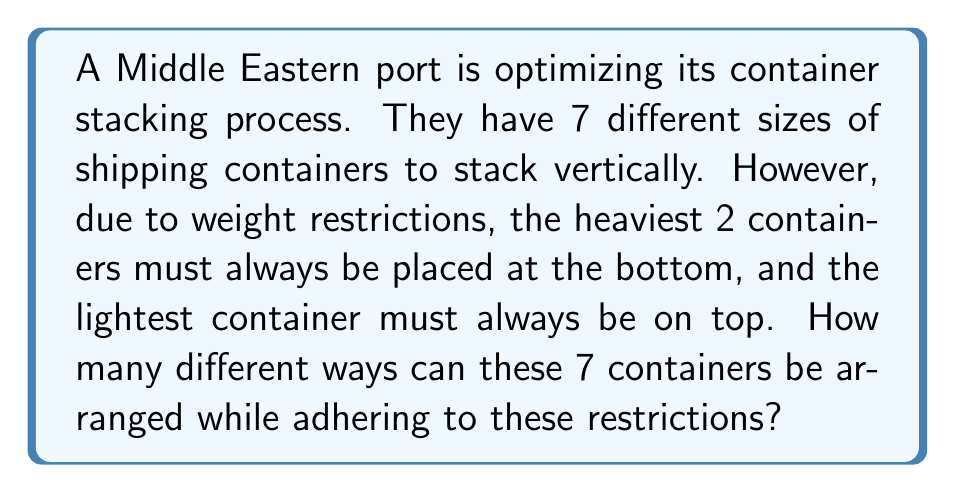Give your solution to this math problem. Let's approach this step-by-step:

1) First, we need to recognize that this is a permutation problem with restrictions.

2) We have 7 containers in total, but their positions are partially fixed:
   - The heaviest 2 containers must be at the bottom (in either order)
   - The lightest container must be on top
   - The remaining 4 containers can be arranged freely in the middle

3) Let's break down the problem:
   a) For the bottom 2 positions, we have 2! = 2 ways to arrange the heaviest containers
   b) The top position is fixed with the lightest container
   c) The middle 4 positions can be arranged in 4! ways

4) According to the multiplication principle, we multiply these together:

   $$ \text{Total arrangements} = 2! \times 4! \times 1 $$

5) Let's calculate:
   $$ 2! \times 4! \times 1 = 2 \times 24 \times 1 = 48 $$

Therefore, there are 48 different ways to arrange the containers while adhering to the given restrictions.
Answer: 48 arrangements 